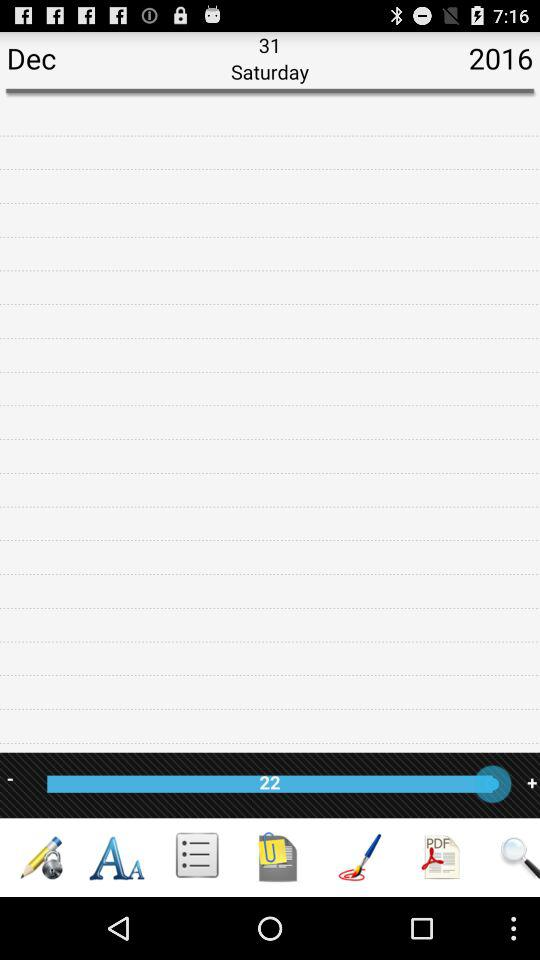What is the day on December 31, 2016? The day is Saturday. 